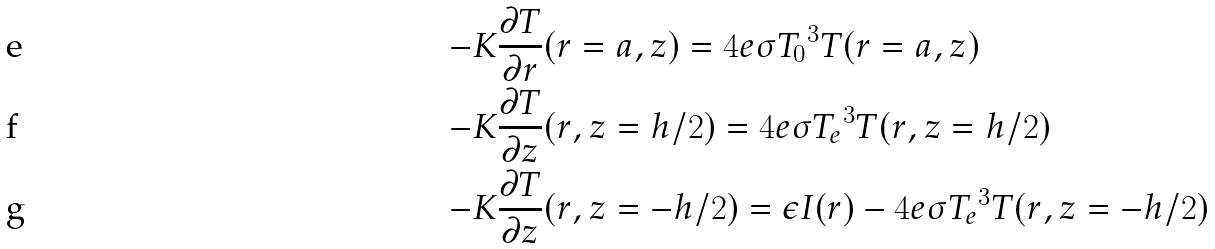Convert formula to latex. <formula><loc_0><loc_0><loc_500><loc_500>- & K \frac { \partial T } { \partial r } ( r = a , z ) = 4 e \sigma { T _ { 0 } } ^ { 3 } T ( r = a , z ) \\ - & K \frac { \partial T } { \partial z } ( r , z = h / 2 ) = 4 e \sigma { T _ { e } } ^ { 3 } T ( r , z = h / 2 ) \\ - & K \frac { \partial T } { \partial z } ( r , z = - h / 2 ) = \epsilon I ( r ) - 4 e \sigma { T _ { e } } ^ { 3 } T ( r , z = - h / 2 )</formula> 